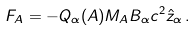Convert formula to latex. <formula><loc_0><loc_0><loc_500><loc_500>F _ { A } = - Q _ { \alpha } ( A ) M _ { A } B _ { \alpha } c ^ { 2 } \hat { z } _ { \alpha } \, .</formula> 